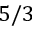<formula> <loc_0><loc_0><loc_500><loc_500>5 / 3</formula> 